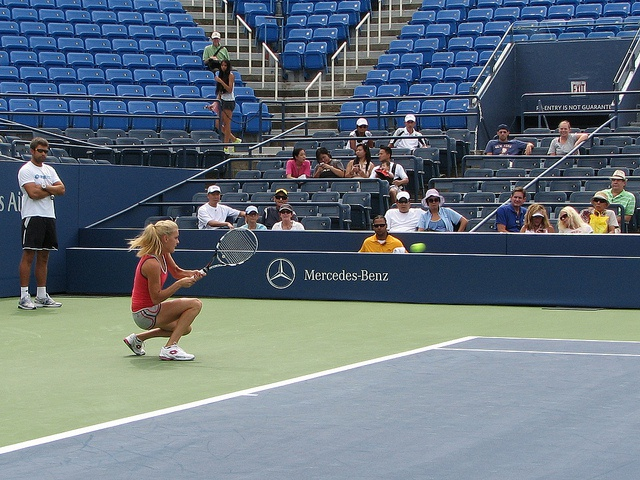Describe the objects in this image and their specific colors. I can see people in gray, black, navy, and darkgray tones, people in gray, brown, and maroon tones, people in gray, black, lightgray, maroon, and darkgray tones, tennis racket in gray, black, darkgray, and navy tones, and people in gray, black, and darkgray tones in this image. 